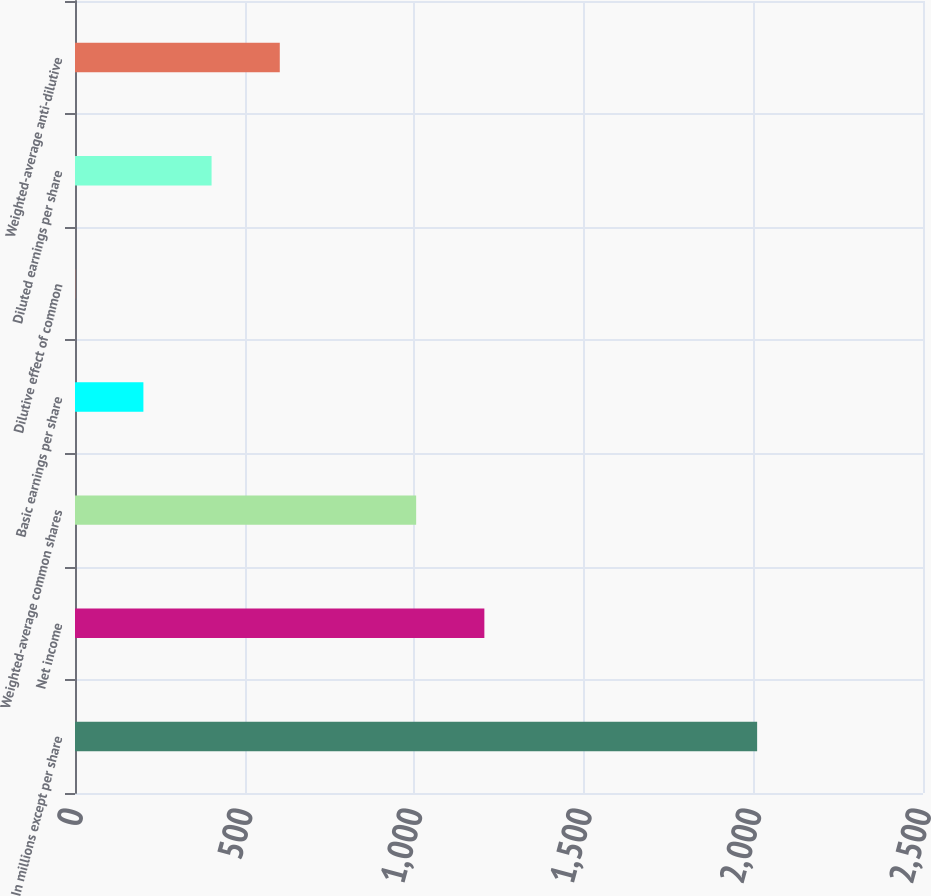<chart> <loc_0><loc_0><loc_500><loc_500><bar_chart><fcel>In millions except per share<fcel>Net income<fcel>Weighted-average common shares<fcel>Basic earnings per share<fcel>Dilutive effect of common<fcel>Diluted earnings per share<fcel>Weighted-average anti-dilutive<nl><fcel>2011<fcel>1206.84<fcel>1005.8<fcel>201.64<fcel>0.6<fcel>402.68<fcel>603.72<nl></chart> 